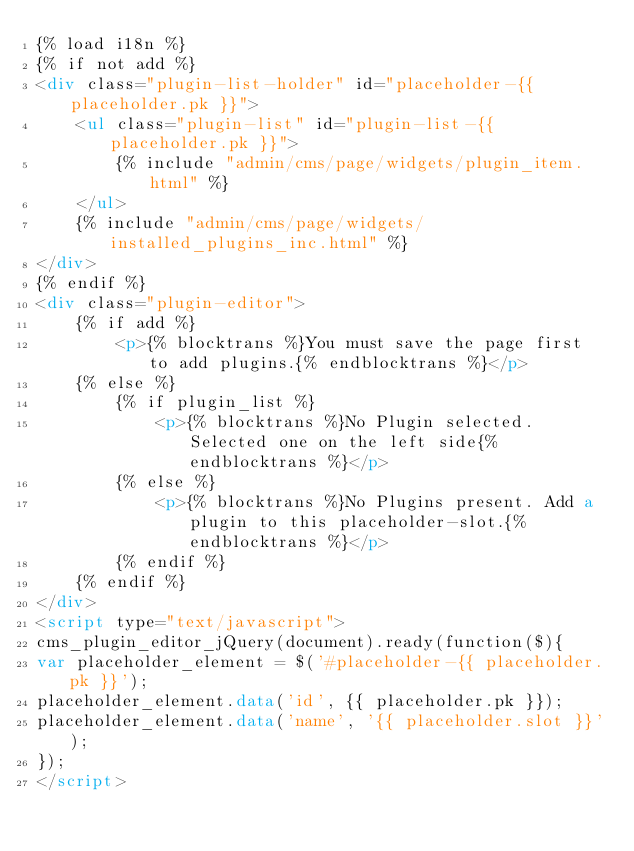<code> <loc_0><loc_0><loc_500><loc_500><_HTML_>{% load i18n %}
{% if not add %}
<div class="plugin-list-holder" id="placeholder-{{ placeholder.pk }}">
	<ul class="plugin-list" id="plugin-list-{{ placeholder.pk }}">
		{% include "admin/cms/page/widgets/plugin_item.html" %}
	</ul>
	{% include "admin/cms/page/widgets/installed_plugins_inc.html" %}
</div>
{% endif %}
<div class="plugin-editor">
	{% if add %}
		<p>{% blocktrans %}You must save the page first to add plugins.{% endblocktrans %}</p>
	{% else %}
		{% if plugin_list %}
			<p>{% blocktrans %}No Plugin selected. Selected one on the left side{% endblocktrans %}</p>
		{% else %}
			<p>{% blocktrans %}No Plugins present. Add a plugin to this placeholder-slot.{% endblocktrans %}</p>
		{% endif %}
	{% endif %}
</div>
<script type="text/javascript">
cms_plugin_editor_jQuery(document).ready(function($){
var placeholder_element = $('#placeholder-{{ placeholder.pk }}');
placeholder_element.data('id', {{ placeholder.pk }});
placeholder_element.data('name', '{{ placeholder.slot }}');
});
</script></code> 